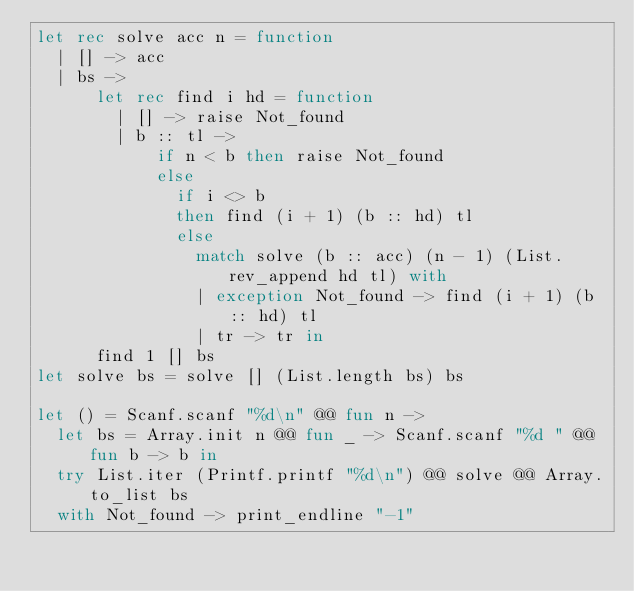<code> <loc_0><loc_0><loc_500><loc_500><_OCaml_>let rec solve acc n = function
  | [] -> acc
  | bs ->
      let rec find i hd = function
        | [] -> raise Not_found
        | b :: tl ->
            if n < b then raise Not_found
            else
              if i <> b
              then find (i + 1) (b :: hd) tl
              else
                match solve (b :: acc) (n - 1) (List.rev_append hd tl) with
                | exception Not_found -> find (i + 1) (b :: hd) tl
                | tr -> tr in
      find 1 [] bs
let solve bs = solve [] (List.length bs) bs

let () = Scanf.scanf "%d\n" @@ fun n ->
  let bs = Array.init n @@ fun _ -> Scanf.scanf "%d " @@ fun b -> b in
  try List.iter (Printf.printf "%d\n") @@ solve @@ Array.to_list bs
  with Not_found -> print_endline "-1"

</code> 